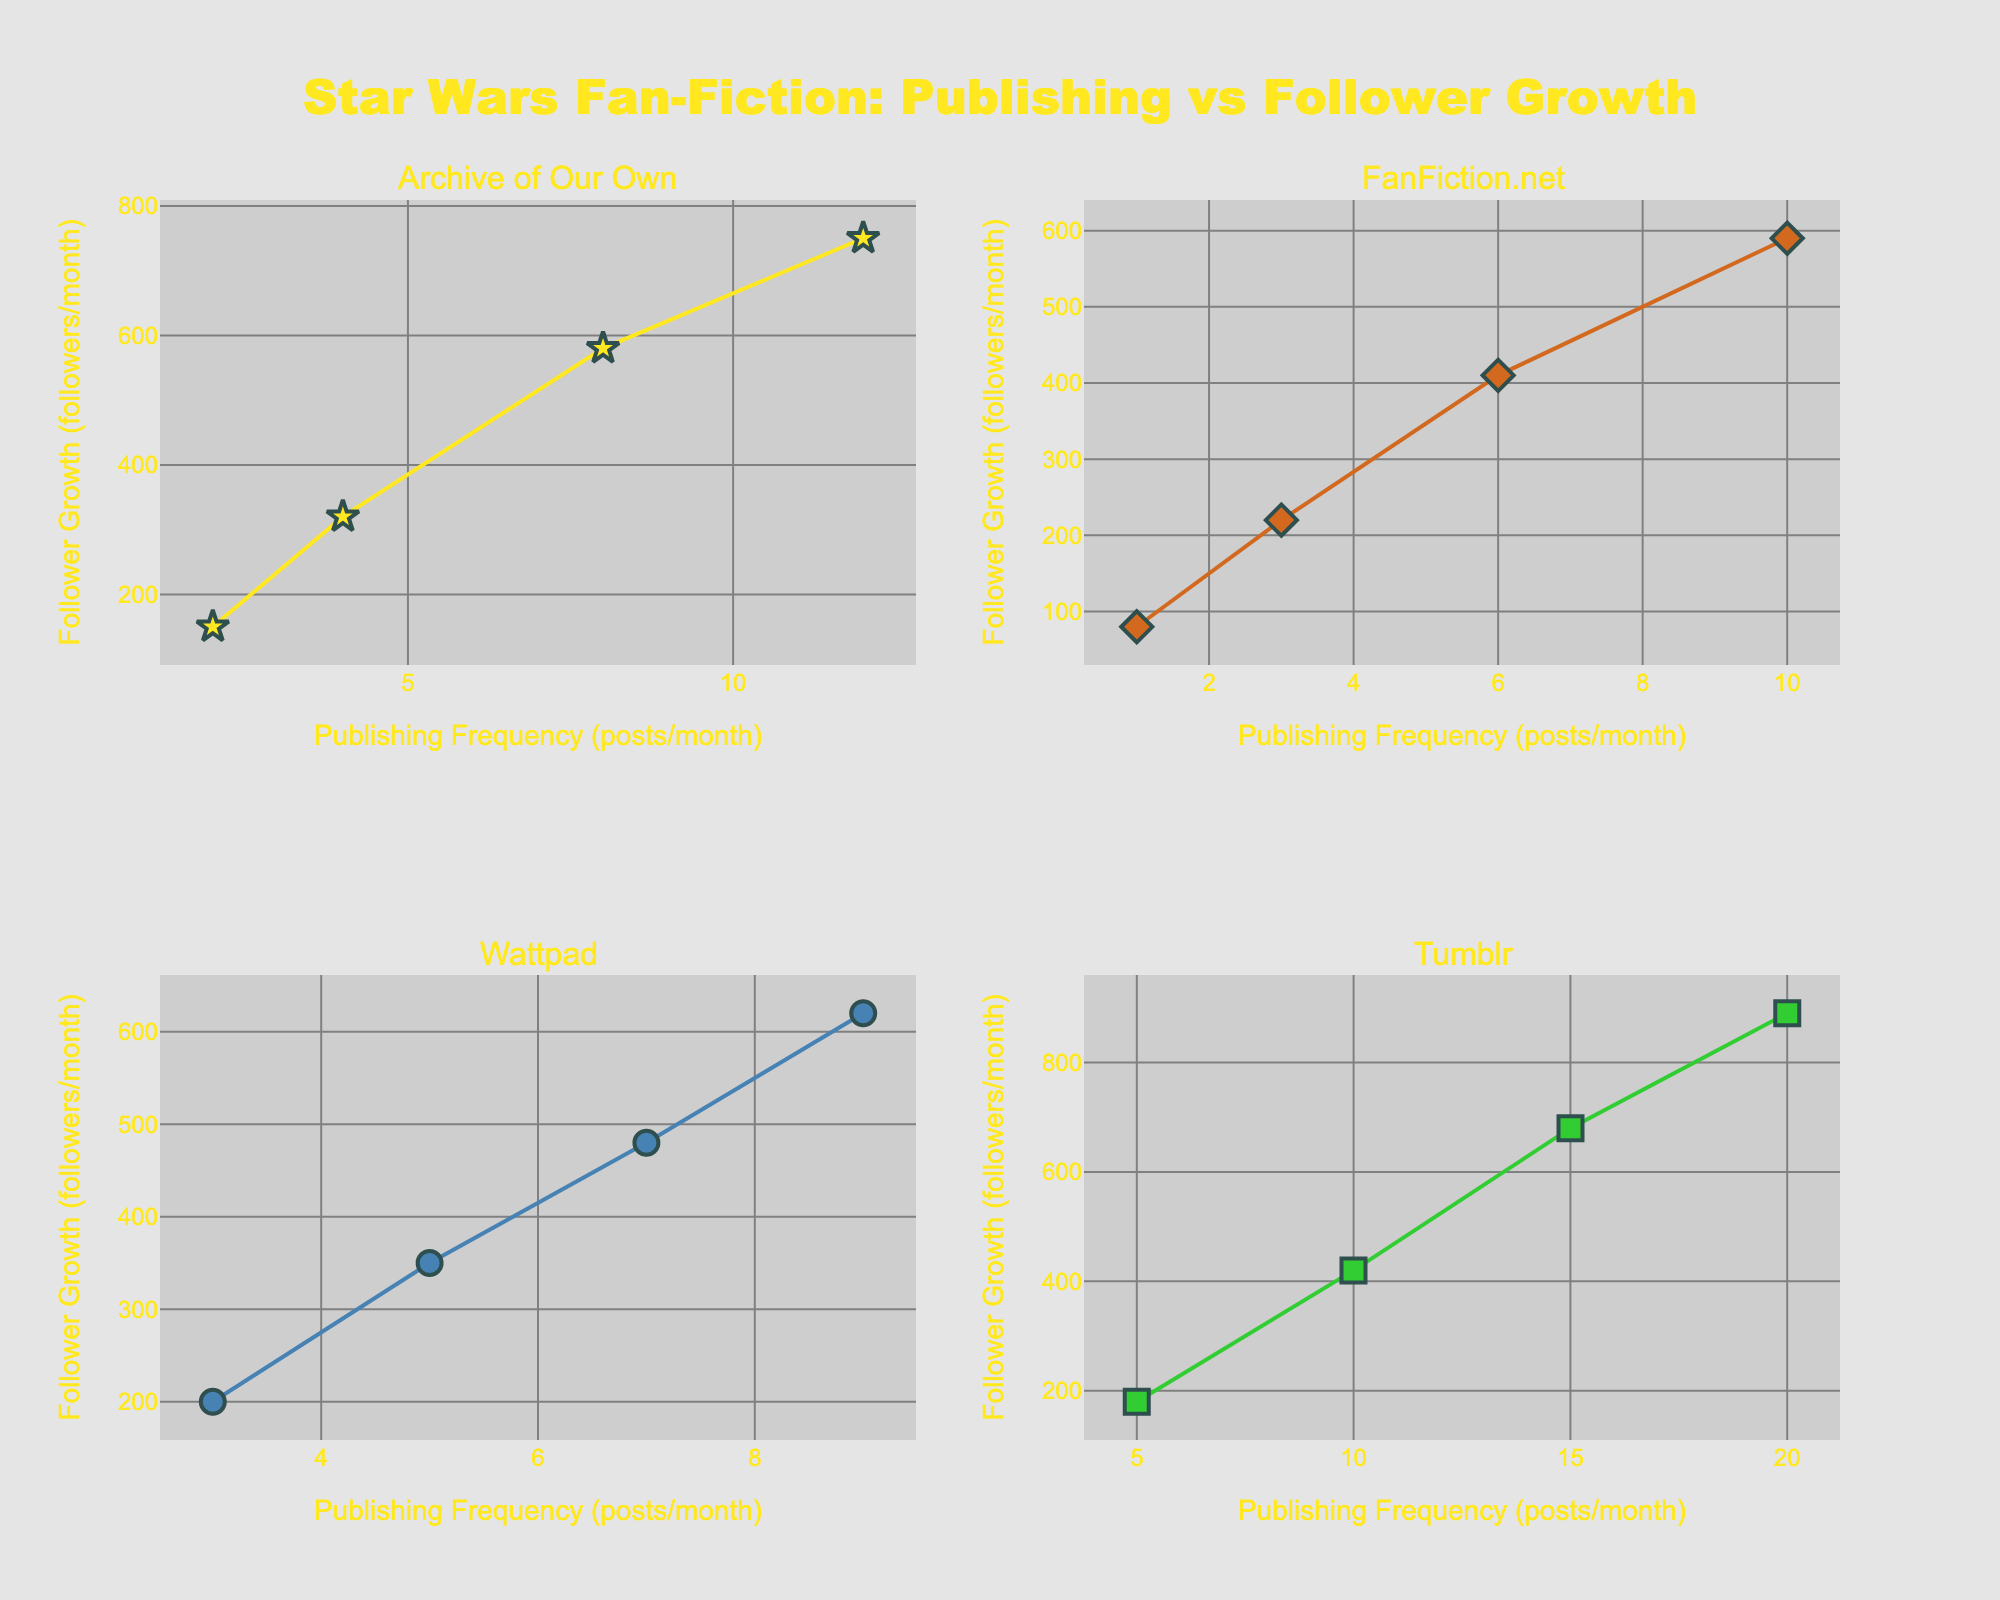How many subplots are present in the figure? The figure is divided into a 2x2 grid, resulting in four subplots, each representing a different website.
Answer: 4 What is the title of the figure? The title of the figure is located at the top center of the plot. It reads "Star Wars Fan-Fiction: Publishing vs Follower Growth."
Answer: Star Wars Fan-Fiction: Publishing vs Follower Growth Which website has the highest publishing frequency in each respective subplot? Each subplot corresponds to a specific website. The websites and their highest publishing frequencies are: Archive of Our Own (12 posts/month), FanFiction.net (10 posts/month), Wattpad (9 posts/month), Tumblr (20 posts/month).
Answer: Archive of Our Own: 12, FanFiction.net: 10, Wattpad: 9, Tumblr: 20 For the "Tumblr" subplot, what is the difference in follower growth between publishing at 10 posts/month and at 15 posts/month? From the "Tumblr" subplot, the follower growth at 10 posts/month is 420, and at 15 posts/month is 680. The difference is 680 - 420 = 260.
Answer: 260 Which website has the highest follower growth for the same publishing frequency of 10 posts/month? Comparisons across the subplots show: Archive of Our Own and Wattpad do not have data for 10 posts/month, FanFiction.net has 590 followers/month, and Tumblr has 420 followers/month. FanFiction.net has the highest follower growth for 10 posts/month.
Answer: FanFiction.net Find the average follower growth for publishing frequency of 5 posts/month across all websites. The follower growths at 5 posts/month are: Wattpad (350 followers/month) and Tumblr (180 followers/month). Average: (350 + 180) / 2 = 265.
Answer: 265 For Wattpad, what is the ratio of follower growth between publishing 9 posts/month and 3 posts/month? From the Wattpad subplot, follower growth at 9 posts/month is 620, and at 3 posts/month is 200. The ratio is calculated as 620 / 200 = 3.1.
Answer: 3.1 Between FanFiction.net and Archive of Our Own, which website shows a higher initial follower growth for the lowest publishing frequency? The initial lowest publishing frequencies are: Archive of Our Own (2 posts/month with 150 followers/month) and FanFiction.net (1 post/month with 80 followers/month). Archive of Our Own has a higher initial follower growth (150 > 80).
Answer: Archive of Our Own In the subplot for Archive of Our Own, what is the increase in follower growth when publishing frequency increases from 4 posts/month to 8 posts/month? For Archive of Our Own, follower growth increases from 320 followers/month at 4 posts/month to 580 followers/month at 8 posts/month. The increase is 580 - 320 = 260.
Answer: 260 